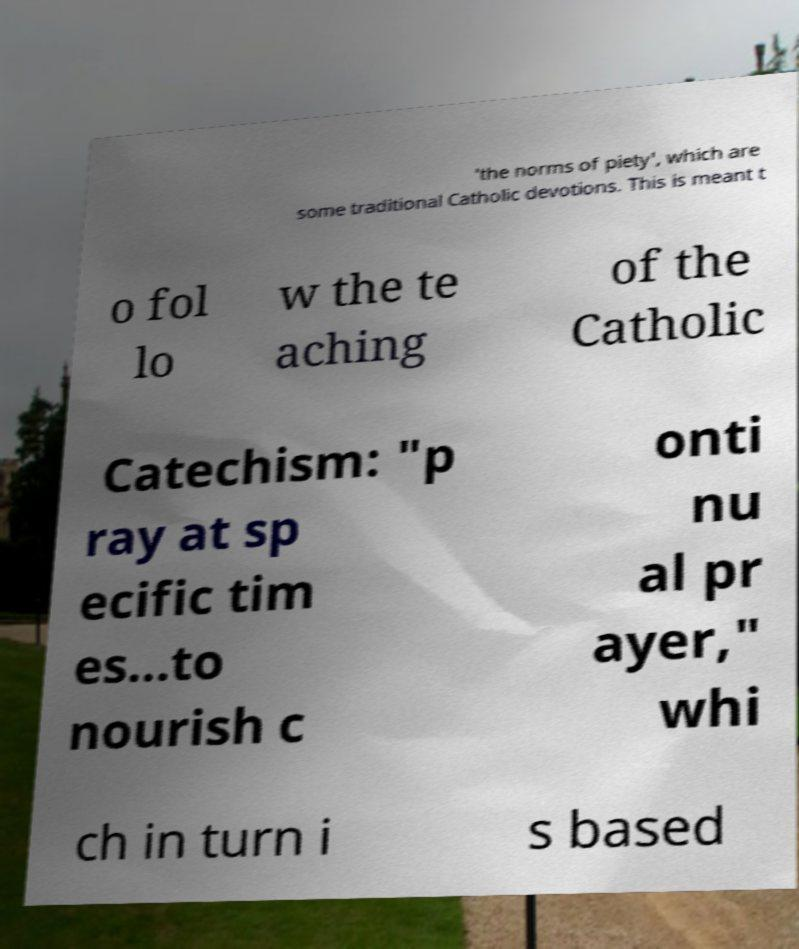Can you accurately transcribe the text from the provided image for me? 'the norms of piety', which are some traditional Catholic devotions. This is meant t o fol lo w the te aching of the Catholic Catechism: "p ray at sp ecific tim es...to nourish c onti nu al pr ayer," whi ch in turn i s based 